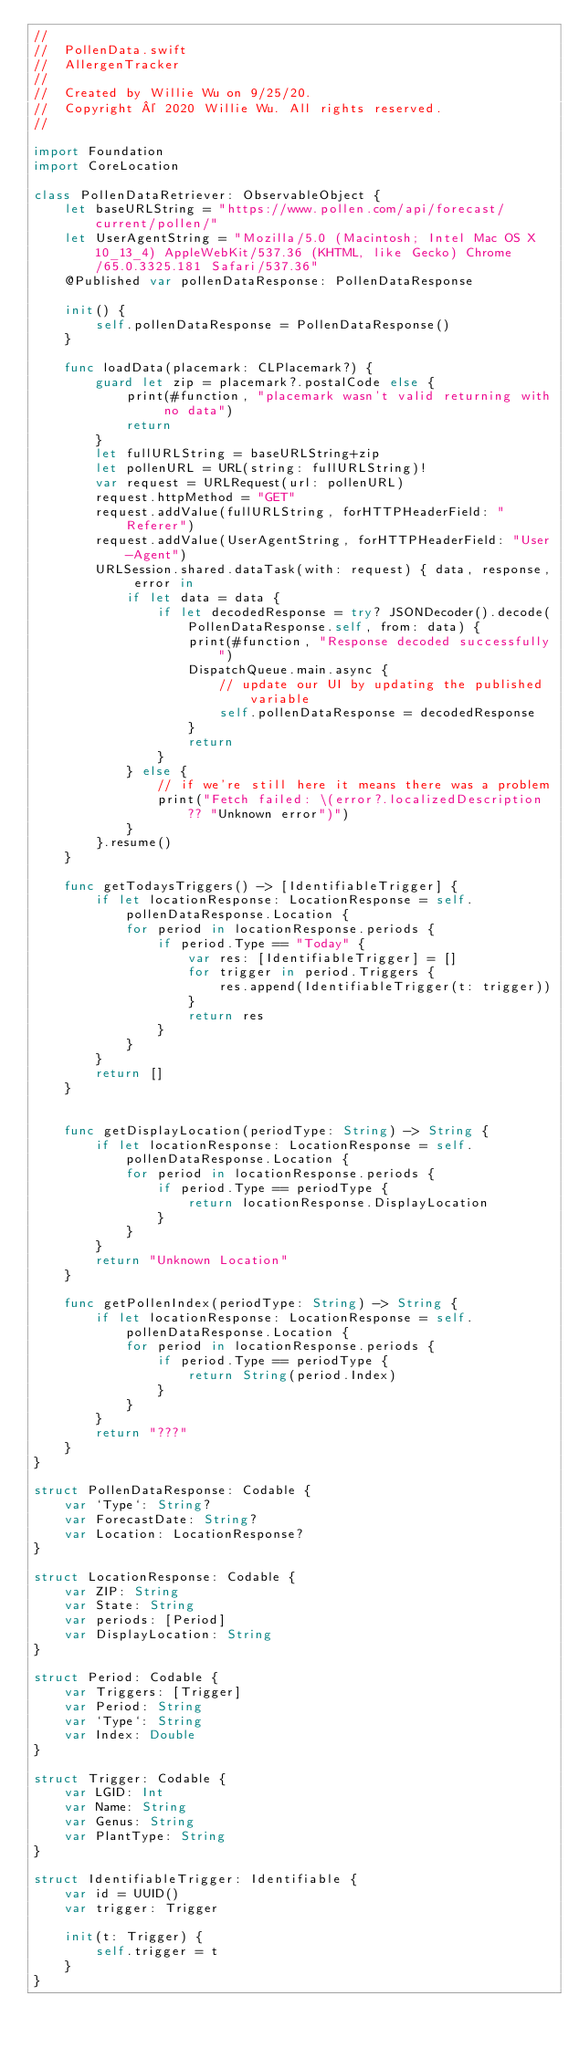<code> <loc_0><loc_0><loc_500><loc_500><_Swift_>//
//  PollenData.swift
//  AllergenTracker
//
//  Created by Willie Wu on 9/25/20.
//  Copyright © 2020 Willie Wu. All rights reserved.
//

import Foundation
import CoreLocation

class PollenDataRetriever: ObservableObject {
    let baseURLString = "https://www.pollen.com/api/forecast/current/pollen/"
    let UserAgentString = "Mozilla/5.0 (Macintosh; Intel Mac OS X 10_13_4) AppleWebKit/537.36 (KHTML, like Gecko) Chrome/65.0.3325.181 Safari/537.36"
    @Published var pollenDataResponse: PollenDataResponse
    
    init() {
        self.pollenDataResponse = PollenDataResponse()
    }
    
    func loadData(placemark: CLPlacemark?) {
        guard let zip = placemark?.postalCode else {
            print(#function, "placemark wasn't valid returning with no data")
            return
        }
        let fullURLString = baseURLString+zip
        let pollenURL = URL(string: fullURLString)!
        var request = URLRequest(url: pollenURL)
        request.httpMethod = "GET"
        request.addValue(fullURLString, forHTTPHeaderField: "Referer")
        request.addValue(UserAgentString, forHTTPHeaderField: "User-Agent")
        URLSession.shared.dataTask(with: request) { data, response, error in
            if let data = data {
                if let decodedResponse = try? JSONDecoder().decode(PollenDataResponse.self, from: data) {
                    print(#function, "Response decoded successfully")
                    DispatchQueue.main.async {
                        // update our UI by updating the published variable
                        self.pollenDataResponse = decodedResponse
                    }
                    return
                }
            } else {
                // if we're still here it means there was a problem
                print("Fetch failed: \(error?.localizedDescription ?? "Unknown error")")
            }
        }.resume()
    }
    
    func getTodaysTriggers() -> [IdentifiableTrigger] {
        if let locationResponse: LocationResponse = self.pollenDataResponse.Location {
            for period in locationResponse.periods {
                if period.Type == "Today" {
                    var res: [IdentifiableTrigger] = []
                    for trigger in period.Triggers {
                        res.append(IdentifiableTrigger(t: trigger))
                    }
                    return res
                }
            }
        }
        return []
    }
    
    
    func getDisplayLocation(periodType: String) -> String {
        if let locationResponse: LocationResponse = self.pollenDataResponse.Location {
            for period in locationResponse.periods {
                if period.Type == periodType {
                    return locationResponse.DisplayLocation
                }
            }
        }
        return "Unknown Location"
    }
    
    func getPollenIndex(periodType: String) -> String {
        if let locationResponse: LocationResponse = self.pollenDataResponse.Location {
            for period in locationResponse.periods {
                if period.Type == periodType {
                    return String(period.Index)
                }
            }
        }
        return "???"
    }
}

struct PollenDataResponse: Codable {
    var `Type`: String?
    var ForecastDate: String?
    var Location: LocationResponse?
}

struct LocationResponse: Codable {
    var ZIP: String
    var State: String
    var periods: [Period]
    var DisplayLocation: String
}

struct Period: Codable {
    var Triggers: [Trigger]
    var Period: String
    var `Type`: String
    var Index: Double
}

struct Trigger: Codable {
    var LGID: Int
    var Name: String
    var Genus: String
    var PlantType: String
}

struct IdentifiableTrigger: Identifiable {
    var id = UUID()
    var trigger: Trigger
    
    init(t: Trigger) {
        self.trigger = t
    }
}
</code> 